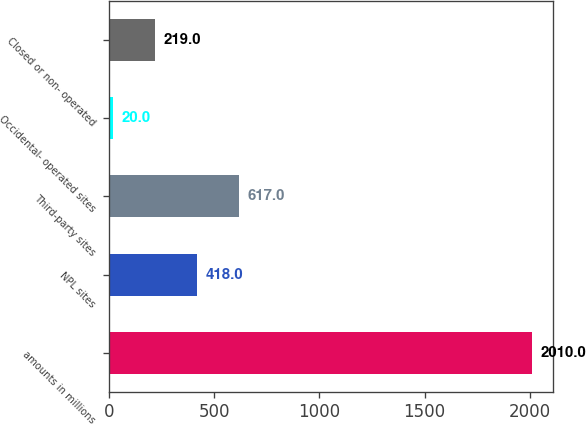<chart> <loc_0><loc_0><loc_500><loc_500><bar_chart><fcel>amounts in millions<fcel>NPL sites<fcel>Third-party sites<fcel>Occidental- operated sites<fcel>Closed or non- operated<nl><fcel>2010<fcel>418<fcel>617<fcel>20<fcel>219<nl></chart> 